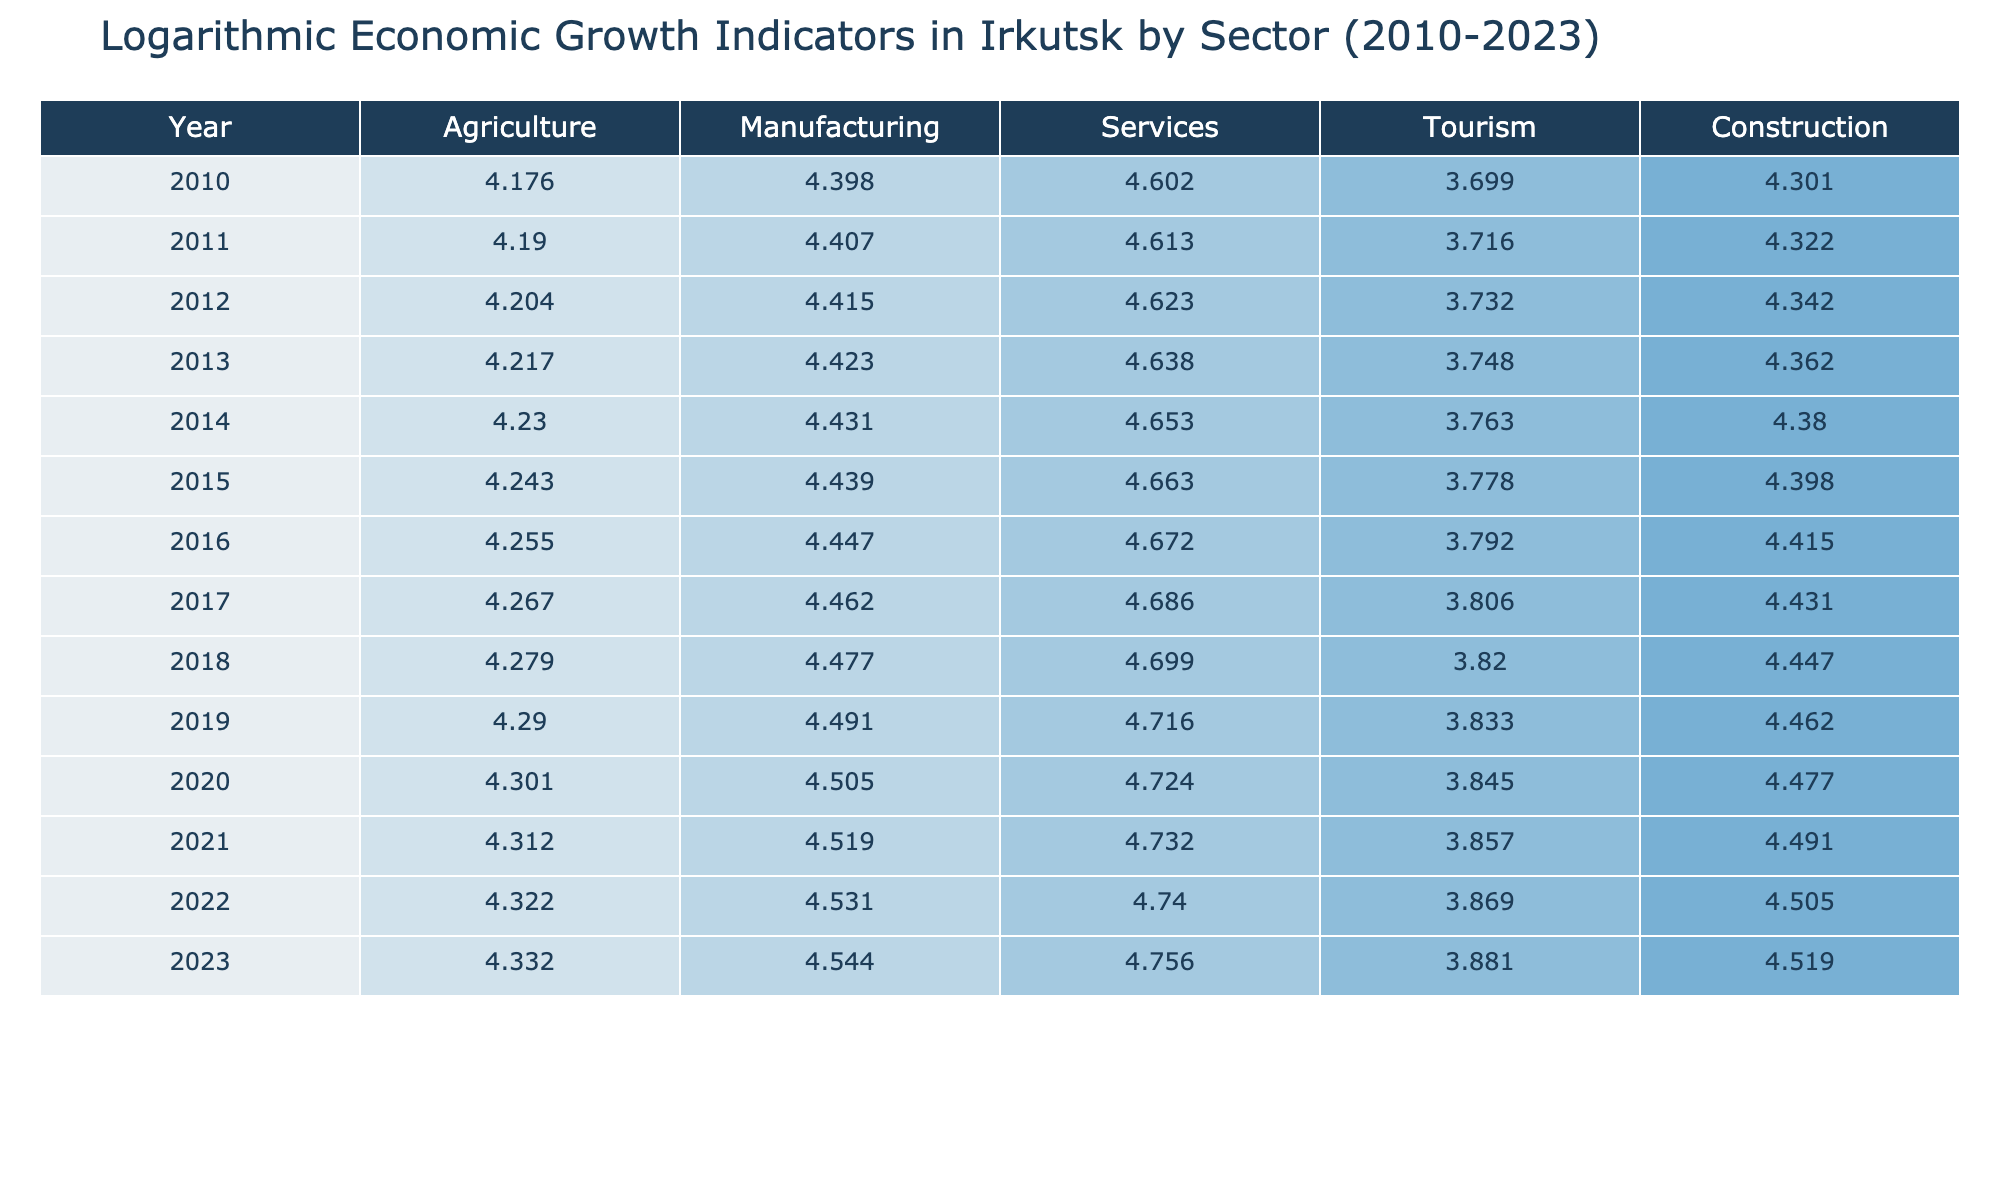What was the value of agriculture in Irkutsk in 2015? Looking at the table for the year 2015, we find the agriculture value listed directly under that year, which is 17500.
Answer: 17500 Which sector had the highest value in 2020? In the year 2020, we compare the values across all sectors: Agriculture (20000), Manufacturing (32000), Services (53000), Tourism (7000), and Construction (30000). The highest value is in the Services sector at 53000.
Answer: Services What was the average growth in the Manufacturing sector from 2010 to 2023? First, we extract the values for the Manufacturing sector from the years 2010 to 2023: 25000, 25500, 26000, 26500, 27000, 27500, 28000, 29000, 30000, 31000, 32000, 33000, 34000, 35000. The sum of these values is 348500, and counting the years gives us 14. Therefore, the average is 348500/14, which is approximately 24821.43.
Answer: 24821.43 Is the value of Tourism higher in 2022 than in 2023? Comparing the values for the Tourism sector in both 2022 (7400) and 2023 (7600), it is clear that 7600 is greater than 7400. Therefore, the statement is true.
Answer: Yes What was the total value for the Services sector in 2018 and 2019 combined? To find the combined total for the Services sector in 2018 (50000) and 2019 (52000), we simply add these two values: 50000 + 52000 = 102000.
Answer: 102000 Which sector showed the least growth over the entire period from 2010 to 2023? We ascertain the growth for each sector from the initial year to the final year: Agriculture: 21500 - 15000 = 6500; Manufacturing: 35000 - 25000 = 10000; Services: 57000 - 40000 = 17000; Tourism: 7600 - 5000 = 2600; Construction: 33000 - 20000 = 13000. The sector with the least growth is Tourism with an increase of only 2600.
Answer: Tourism What year saw the highest logarithmic value for Construction? We check the Construction values across the years: 20000, 21000, 22000, 23000, 24000, 25000, 26000, 27000, 28000, 29000, 30000, 31000, 32000, and 33000. The highest value is 33000 in 2023.
Answer: 2023 Is the value of Agriculture in 2023 lower than that in 2010? Comparing the values, Agriculture in 2023 is 21500 while in 2010 it was 15000. Since 21500 is greater than 15000, the statement is false.
Answer: No 